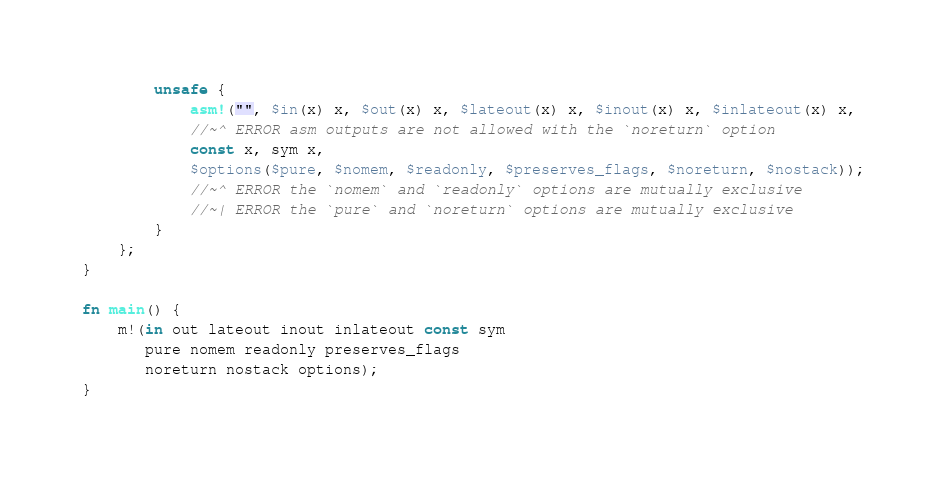<code> <loc_0><loc_0><loc_500><loc_500><_Rust_>        unsafe {
            asm!("", $in(x) x, $out(x) x, $lateout(x) x, $inout(x) x, $inlateout(x) x,
            //~^ ERROR asm outputs are not allowed with the `noreturn` option
            const x, sym x,
            $options($pure, $nomem, $readonly, $preserves_flags, $noreturn, $nostack));
            //~^ ERROR the `nomem` and `readonly` options are mutually exclusive
            //~| ERROR the `pure` and `noreturn` options are mutually exclusive
        }
    };
}

fn main() {
    m!(in out lateout inout inlateout const sym
       pure nomem readonly preserves_flags
       noreturn nostack options);
}
</code> 